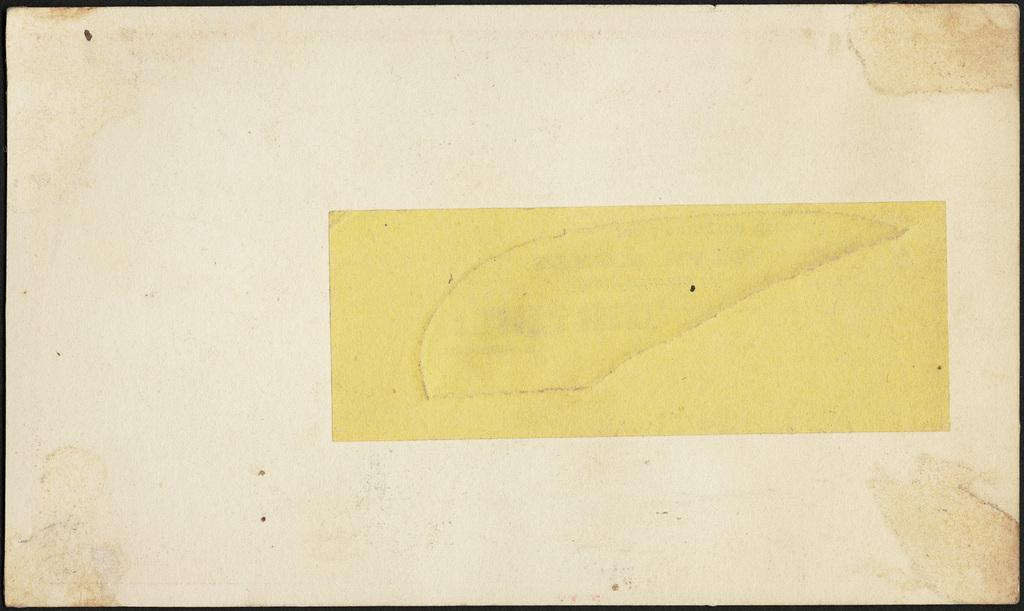What is present in the image? There is a paper in the image. Can you describe the paper in more detail? The paper has borders. What type of skirt is depicted on the paper in the image? There is no skirt present in the image; it only features a paper with borders. 